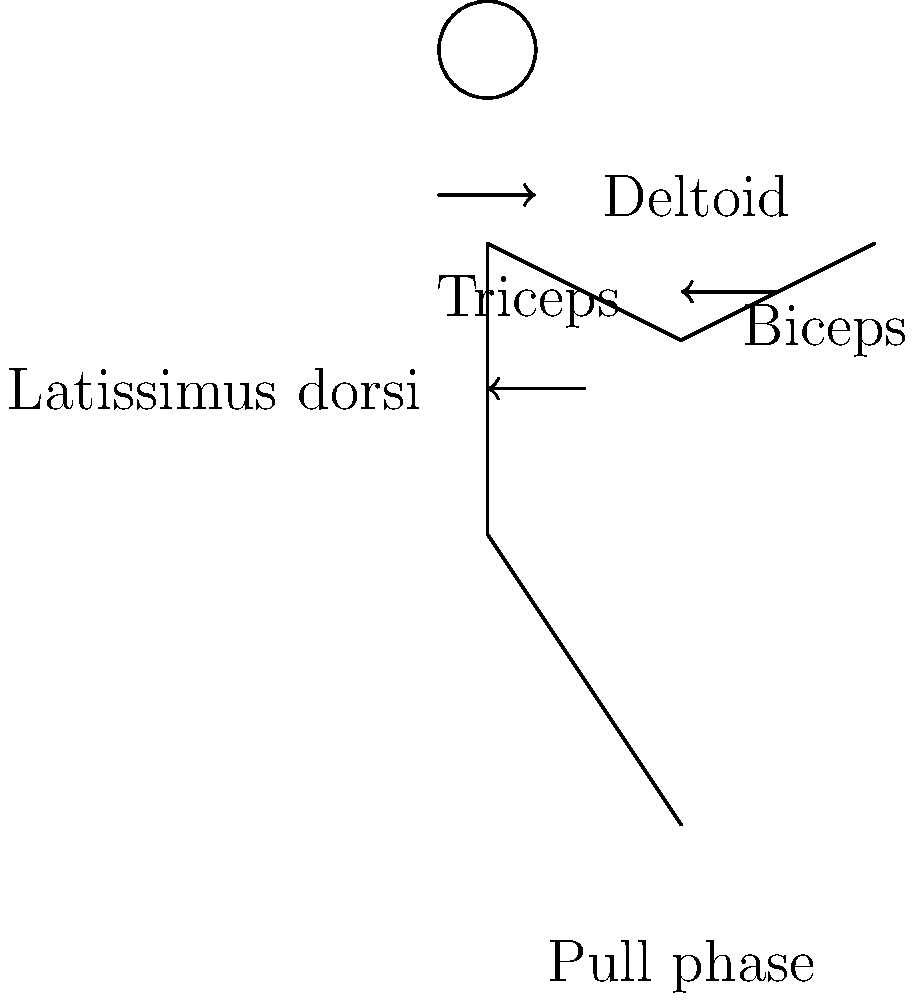In the pull phase of the freestyle stroke, which muscle group is primarily responsible for generating the propulsive force, as illustrated in the stick figure diagram? To answer this question, let's break down the muscle activation patterns during the pull phase of the freestyle stroke:

1. The pull phase begins when the hand enters the water and starts moving backward.

2. The diagram shows a stick figure in the middle of the pull phase, with arrows indicating muscle activation.

3. The major muscle groups involved in this phase are:
   a) Deltoid: Initiates the pull and helps with shoulder rotation
   b) Biceps: Assists in flexing the elbow during the pull
   c) Triceps: Helps to extend the arm at the end of the pull
   d) Latissimus dorsi: Provides the main propulsive force

4. The largest arrow in the diagram points to the latissimus dorsi, indicating its primary role in this phase.

5. The latissimus dorsi, also known as the "lats," is a large, flat muscle on the back that connects the arm to the spine and hip.

6. During the pull phase, the latissimus dorsi contracts powerfully to pull the arm backward through the water, creating the main propulsive force that moves the swimmer forward.

7. While other muscles contribute to the stroke, the latissimus dorsi is the primary muscle responsible for generating the propulsive force during the pull phase of the freestyle stroke.
Answer: Latissimus dorsi 